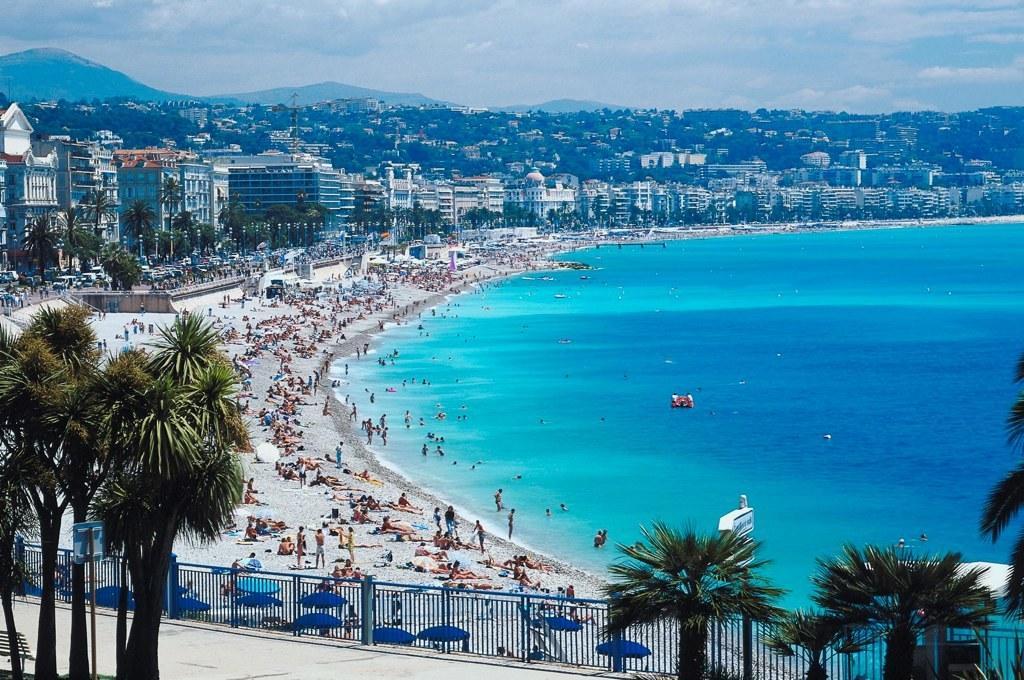Please provide a concise description of this image. In this picture I can see the iron railing at the bottom, in the middle there are group of people, in the background I can see the trees, buildings. At the top there is the sky. 